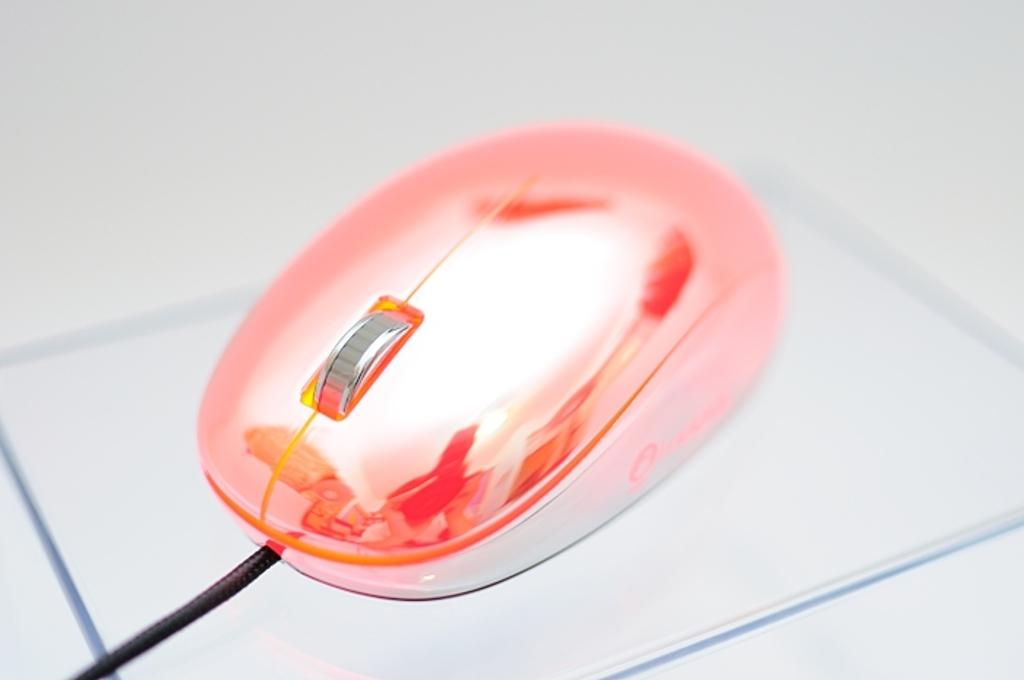What device is visible in the image? There is a computer mouse in the image. Is there anything connected to the computer mouse? Yes, there is a black wire connected to the computer mouse. What type of vacation is being planned with the rice and ticket in the image? There is no mention of a vacation, rice, or ticket in the image; it only features a computer mouse and a black wire. 